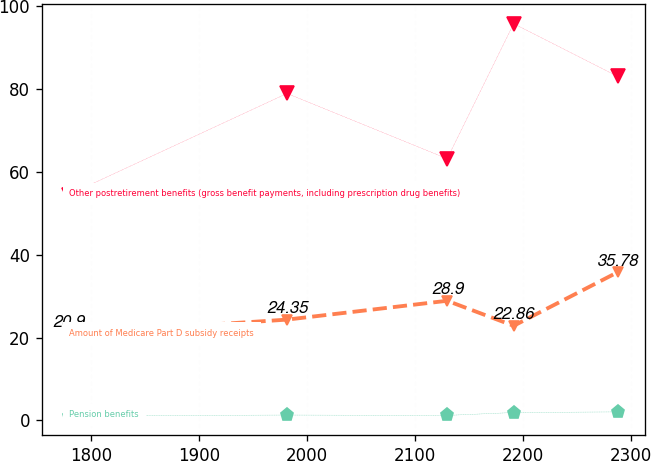<chart> <loc_0><loc_0><loc_500><loc_500><line_chart><ecel><fcel>Other postretirement benefits (gross benefit payments, including prescription drug benefits)<fcel>Amount of Medicare Part D subsidy receipts<fcel>Pension benefits<nl><fcel>1779.58<fcel>54.55<fcel>20.9<fcel>1.13<nl><fcel>1981.39<fcel>78.96<fcel>24.35<fcel>1.31<nl><fcel>2129.71<fcel>63.2<fcel>28.9<fcel>1.22<nl><fcel>2191.25<fcel>95.81<fcel>22.86<fcel>1.92<nl><fcel>2287.44<fcel>83.09<fcel>35.78<fcel>2.07<nl></chart> 